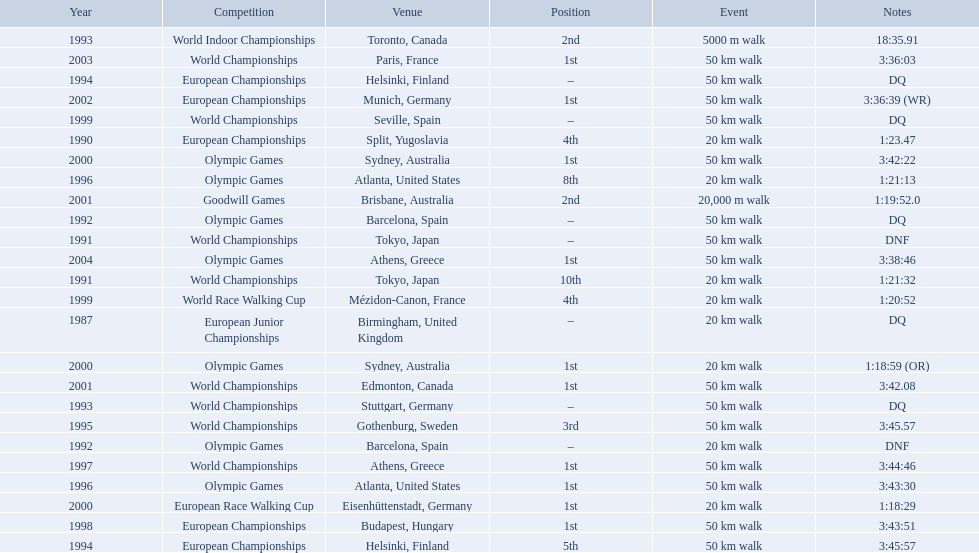In 1990 what position did robert korzeniowski place? 4th. In 1993 what was robert korzeniowski's place in the world indoor championships? 2nd. How long did the 50km walk in 2004 olympic cost? 3:38:46. 